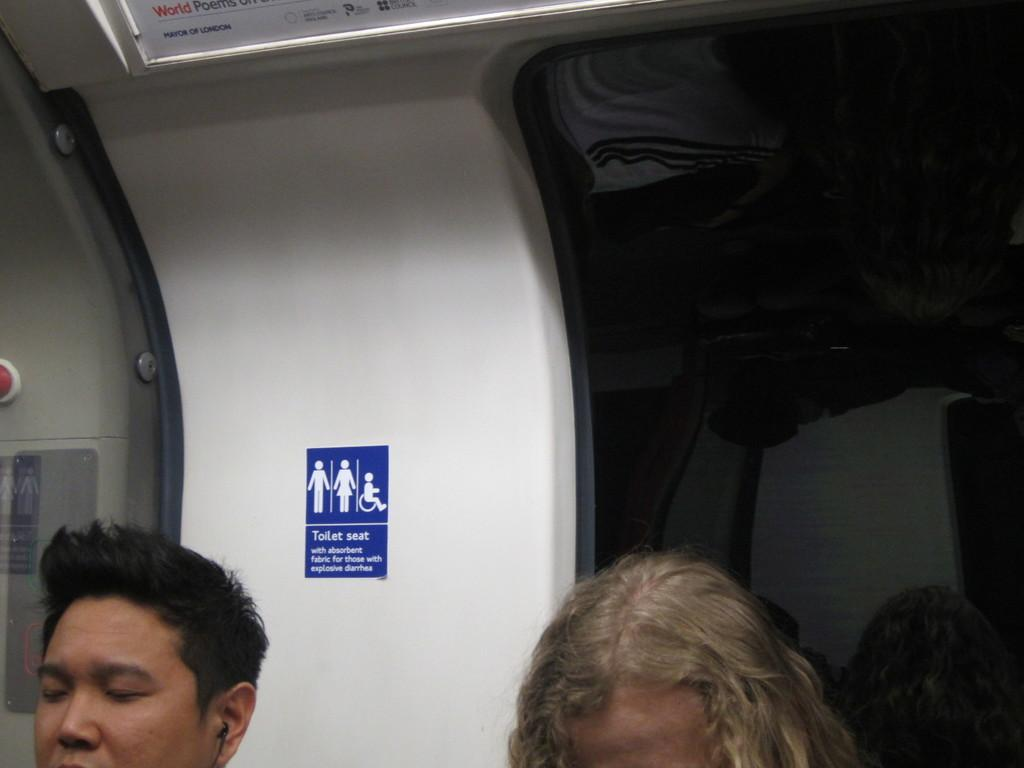How many persons' heads are visible in the image? There are two persons' heads in the image. What is the color of the wall in the background? The wall in the background is white. What is attached to the white wall? A blue color sticker is attached to the white wall. What is the color of the background in the image? The background is black. What type of cushion is being offered on the railway in the image? There is no cushion or railway present in the image. 